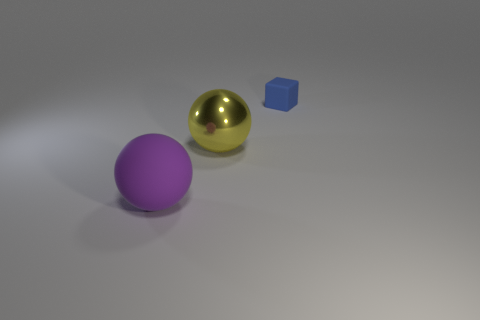Subtract all yellow spheres. How many spheres are left? 1 Add 1 tiny gray shiny things. How many objects exist? 4 Subtract 1 blocks. How many blocks are left? 0 Subtract all gray spheres. Subtract all blue cylinders. How many spheres are left? 2 Subtract all gray cylinders. How many green blocks are left? 0 Subtract all brown metallic cylinders. Subtract all large purple things. How many objects are left? 2 Add 2 blue matte cubes. How many blue matte cubes are left? 3 Add 1 blue cubes. How many blue cubes exist? 2 Subtract 0 yellow cylinders. How many objects are left? 3 Subtract all balls. How many objects are left? 1 